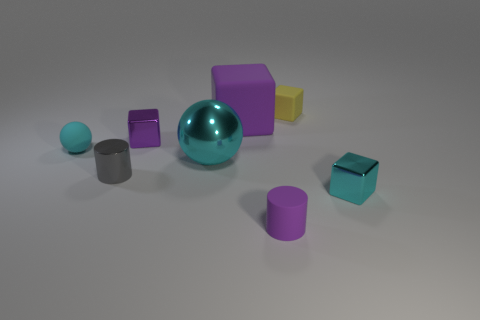Subtract 1 blocks. How many blocks are left? 3 Add 2 small cyan shiny blocks. How many objects exist? 10 Subtract all cylinders. How many objects are left? 6 Add 4 big metallic things. How many big metallic things are left? 5 Add 5 yellow matte things. How many yellow matte things exist? 6 Subtract 1 cyan blocks. How many objects are left? 7 Subtract all cyan metal balls. Subtract all rubber spheres. How many objects are left? 6 